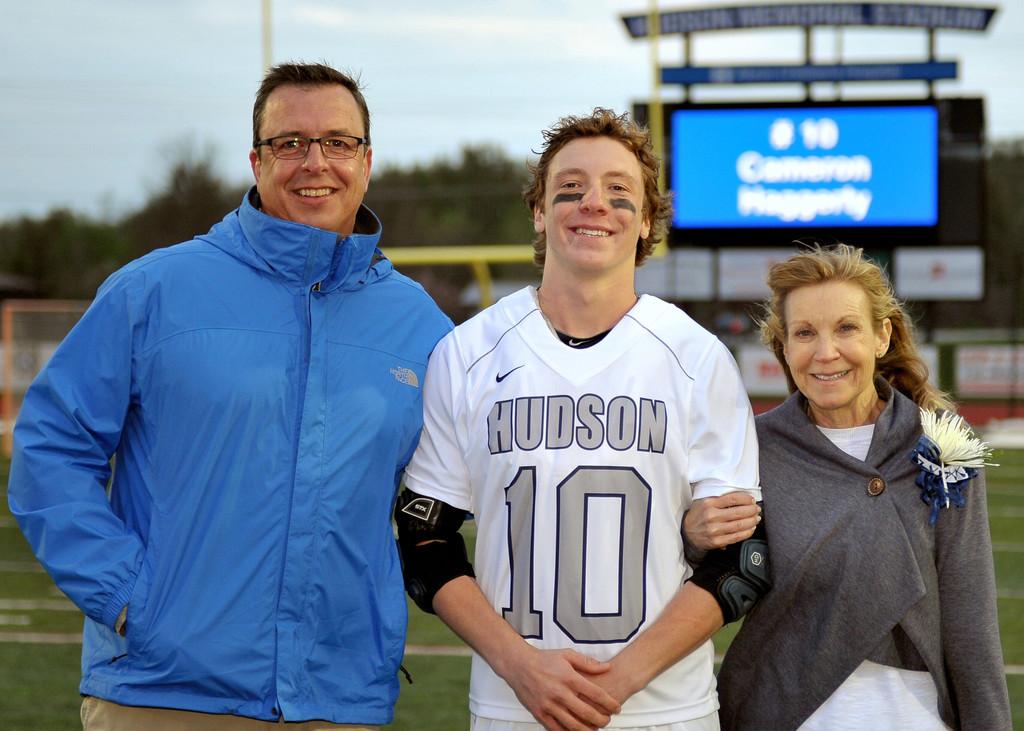What word is printed above the number "10" on this player's shirt?
Offer a terse response. Hudson. 